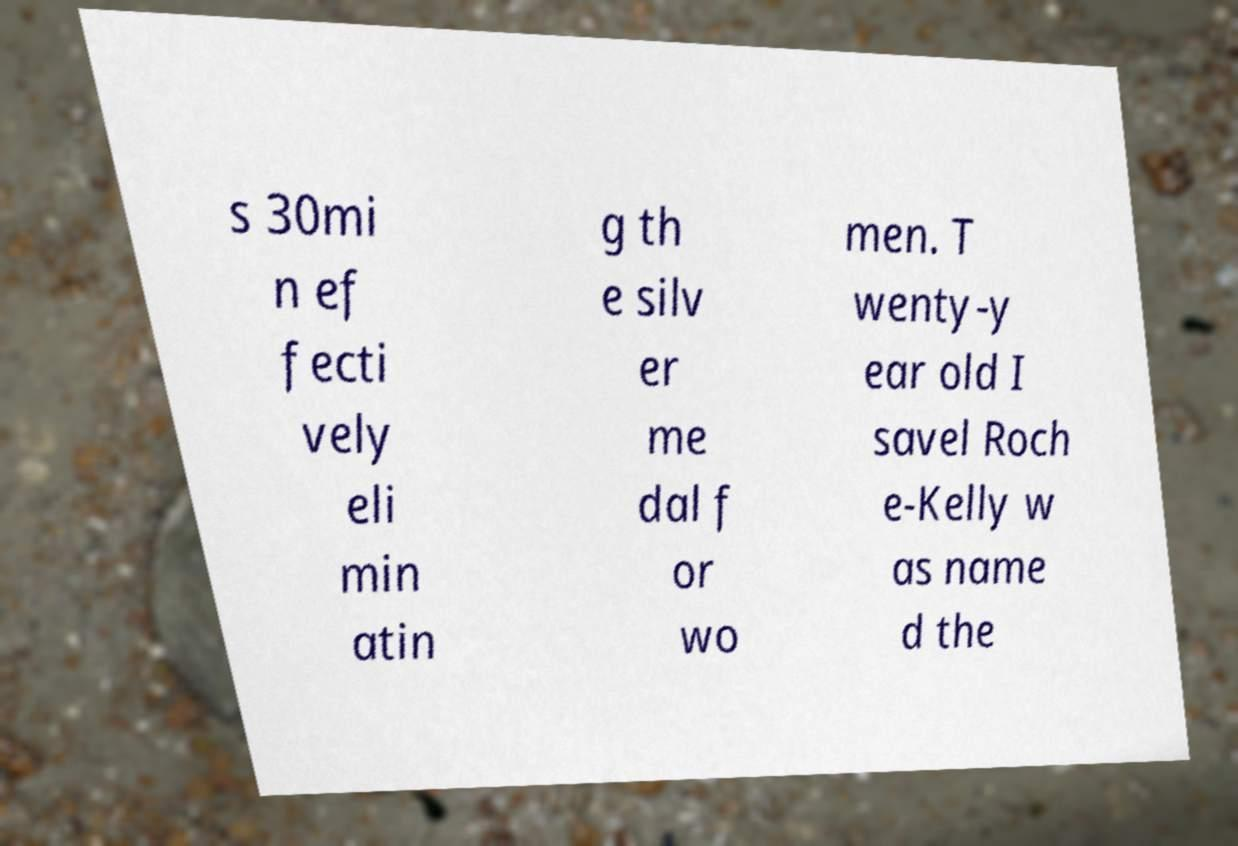Can you accurately transcribe the text from the provided image for me? s 30mi n ef fecti vely eli min atin g th e silv er me dal f or wo men. T wenty-y ear old I savel Roch e-Kelly w as name d the 